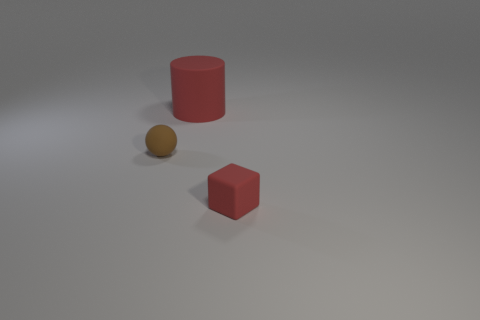The object that is both left of the small red object and right of the brown matte thing has what shape?
Your answer should be compact. Cylinder. What is the size of the red rubber object in front of the red thing behind the tiny brown rubber object?
Your answer should be very brief. Small. How many other things are the same color as the tiny matte sphere?
Offer a very short reply. 0. What material is the tiny ball?
Your response must be concise. Rubber. Is there a large matte object?
Make the answer very short. Yes. Is the number of cubes in front of the small matte cube the same as the number of small gray metallic cylinders?
Your response must be concise. Yes. How many tiny objects are either cubes or brown shiny spheres?
Your answer should be compact. 1. There is a tiny rubber object that is the same color as the large matte object; what is its shape?
Provide a short and direct response. Cube. Is the red thing to the right of the matte cylinder made of the same material as the sphere?
Ensure brevity in your answer.  Yes. What material is the red object that is right of the rubber cylinder behind the rubber ball?
Your answer should be very brief. Rubber. 